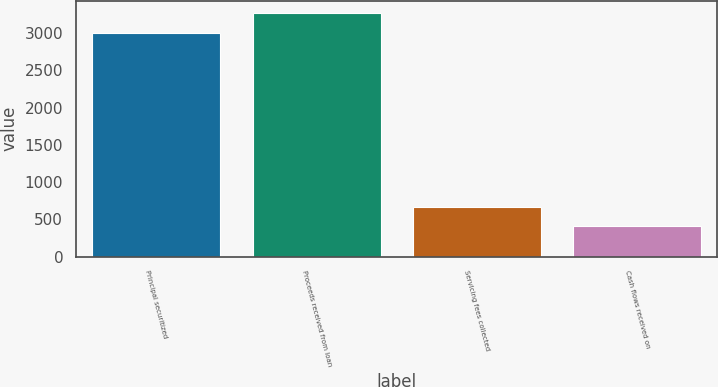Convert chart. <chart><loc_0><loc_0><loc_500><loc_500><bar_chart><fcel>Principal securitized<fcel>Proceeds received from loan<fcel>Servicing fees collected<fcel>Cash flows received on<nl><fcel>3008<fcel>3269.5<fcel>668.5<fcel>407<nl></chart> 